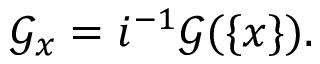Convert formula to latex. <formula><loc_0><loc_0><loc_500><loc_500>{ \mathcal { G } } _ { x } = i ^ { - 1 } { \mathcal { G } } ( \{ x \} ) .</formula> 